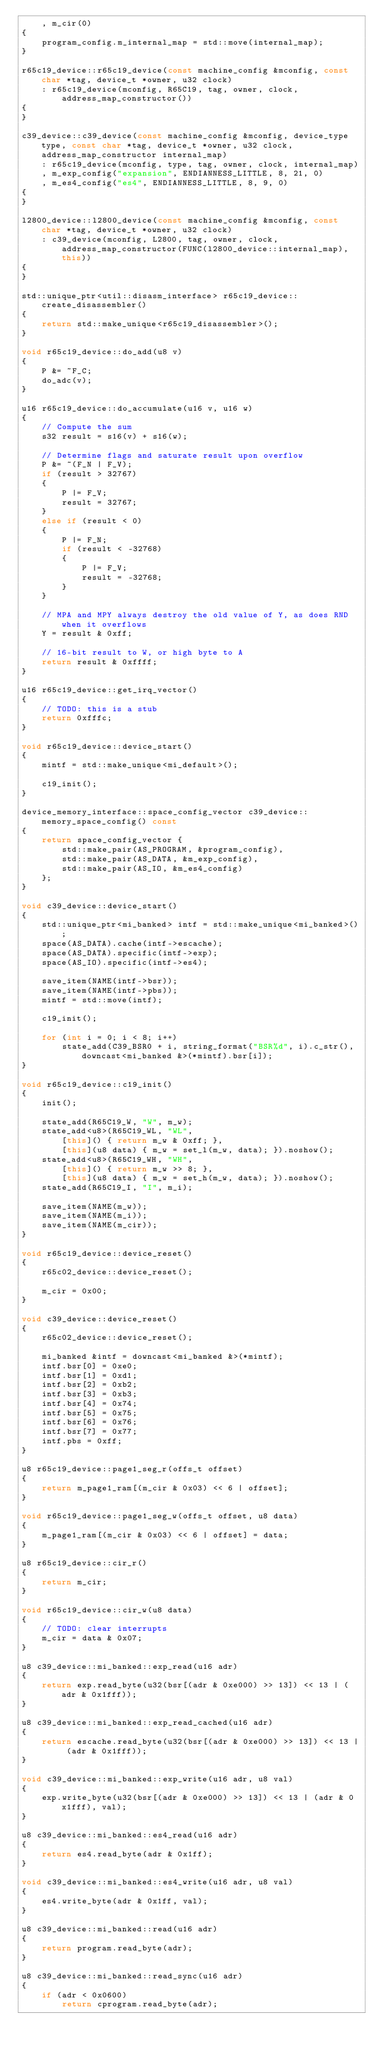<code> <loc_0><loc_0><loc_500><loc_500><_C++_>	, m_cir(0)
{
	program_config.m_internal_map = std::move(internal_map);
}

r65c19_device::r65c19_device(const machine_config &mconfig, const char *tag, device_t *owner, u32 clock)
	: r65c19_device(mconfig, R65C19, tag, owner, clock, address_map_constructor())
{
}

c39_device::c39_device(const machine_config &mconfig, device_type type, const char *tag, device_t *owner, u32 clock, address_map_constructor internal_map)
	: r65c19_device(mconfig, type, tag, owner, clock, internal_map)
	, m_exp_config("expansion", ENDIANNESS_LITTLE, 8, 21, 0)
	, m_es4_config("es4", ENDIANNESS_LITTLE, 8, 9, 0)
{
}

l2800_device::l2800_device(const machine_config &mconfig, const char *tag, device_t *owner, u32 clock)
	: c39_device(mconfig, L2800, tag, owner, clock, address_map_constructor(FUNC(l2800_device::internal_map), this))
{
}

std::unique_ptr<util::disasm_interface> r65c19_device::create_disassembler()
{
	return std::make_unique<r65c19_disassembler>();
}

void r65c19_device::do_add(u8 v)
{
	P &= ~F_C;
	do_adc(v);
}

u16 r65c19_device::do_accumulate(u16 v, u16 w)
{
	// Compute the sum
	s32 result = s16(v) + s16(w);

	// Determine flags and saturate result upon overflow
	P &= ~(F_N | F_V);
	if (result > 32767)
	{
		P |= F_V;
		result = 32767;
	}
	else if (result < 0)
	{
		P |= F_N;
		if (result < -32768)
		{
			P |= F_V;
			result = -32768;
		}
	}

	// MPA and MPY always destroy the old value of Y, as does RND when it overflows
	Y = result & 0xff;

	// 16-bit result to W, or high byte to A
	return result & 0xffff;
}

u16 r65c19_device::get_irq_vector()
{
	// TODO: this is a stub
	return 0xfffc;
}

void r65c19_device::device_start()
{
	mintf = std::make_unique<mi_default>();

	c19_init();
}

device_memory_interface::space_config_vector c39_device::memory_space_config() const
{
	return space_config_vector {
		std::make_pair(AS_PROGRAM, &program_config),
		std::make_pair(AS_DATA, &m_exp_config),
		std::make_pair(AS_IO, &m_es4_config)
	};
}

void c39_device::device_start()
{
	std::unique_ptr<mi_banked> intf = std::make_unique<mi_banked>();
	space(AS_DATA).cache(intf->escache);
	space(AS_DATA).specific(intf->exp);
	space(AS_IO).specific(intf->es4);

	save_item(NAME(intf->bsr));
	save_item(NAME(intf->pbs));
	mintf = std::move(intf);

	c19_init();

	for (int i = 0; i < 8; i++)
		state_add(C39_BSR0 + i, string_format("BSR%d", i).c_str(), downcast<mi_banked &>(*mintf).bsr[i]);
}

void r65c19_device::c19_init()
{
	init();

	state_add(R65C19_W, "W", m_w);
	state_add<u8>(R65C19_WL, "WL",
		[this]() { return m_w & 0xff; },
		[this](u8 data) { m_w = set_l(m_w, data); }).noshow();
	state_add<u8>(R65C19_WH, "WH",
		[this]() { return m_w >> 8; },
		[this](u8 data) { m_w = set_h(m_w, data); }).noshow();
	state_add(R65C19_I, "I", m_i);

	save_item(NAME(m_w));
	save_item(NAME(m_i));
	save_item(NAME(m_cir));
}

void r65c19_device::device_reset()
{
	r65c02_device::device_reset();

	m_cir = 0x00;
}

void c39_device::device_reset()
{
	r65c02_device::device_reset();

	mi_banked &intf = downcast<mi_banked &>(*mintf);
	intf.bsr[0] = 0xe0;
	intf.bsr[1] = 0xd1;
	intf.bsr[2] = 0xb2;
	intf.bsr[3] = 0xb3;
	intf.bsr[4] = 0x74;
	intf.bsr[5] = 0x75;
	intf.bsr[6] = 0x76;
	intf.bsr[7] = 0x77;
	intf.pbs = 0xff;
}

u8 r65c19_device::page1_seg_r(offs_t offset)
{
	return m_page1_ram[(m_cir & 0x03) << 6 | offset];
}

void r65c19_device::page1_seg_w(offs_t offset, u8 data)
{
	m_page1_ram[(m_cir & 0x03) << 6 | offset] = data;
}

u8 r65c19_device::cir_r()
{
	return m_cir;
}

void r65c19_device::cir_w(u8 data)
{
	// TODO: clear interrupts
	m_cir = data & 0x07;
}

u8 c39_device::mi_banked::exp_read(u16 adr)
{
	return exp.read_byte(u32(bsr[(adr & 0xe000) >> 13]) << 13 | (adr & 0x1fff));
}

u8 c39_device::mi_banked::exp_read_cached(u16 adr)
{
	return escache.read_byte(u32(bsr[(adr & 0xe000) >> 13]) << 13 | (adr & 0x1fff));
}

void c39_device::mi_banked::exp_write(u16 adr, u8 val)
{
	exp.write_byte(u32(bsr[(adr & 0xe000) >> 13]) << 13 | (adr & 0x1fff), val);
}

u8 c39_device::mi_banked::es4_read(u16 adr)
{
	return es4.read_byte(adr & 0x1ff);
}

void c39_device::mi_banked::es4_write(u16 adr, u8 val)
{
	es4.write_byte(adr & 0x1ff, val);
}

u8 c39_device::mi_banked::read(u16 adr)
{
	return program.read_byte(adr);
}

u8 c39_device::mi_banked::read_sync(u16 adr)
{
	if (adr < 0x0600)
		return cprogram.read_byte(adr);</code> 